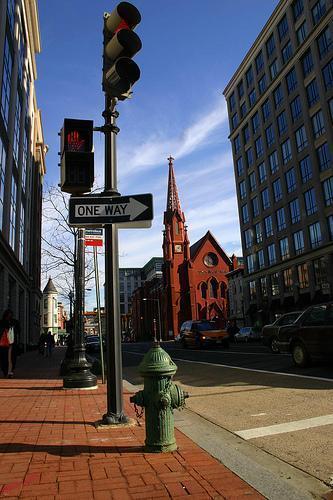How many traffic lights are there?
Give a very brief answer. 1. 